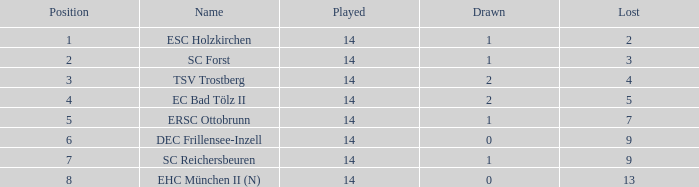Which Points is the highest one that has a Drawn smaller than 2, and a Name of esc holzkirchen, and Played smaller than 14? None. 